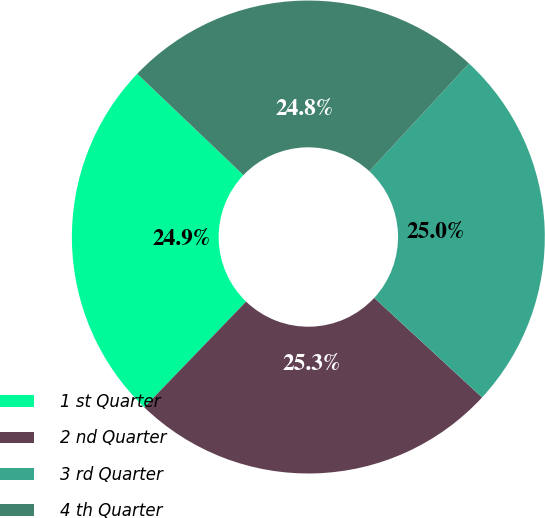Convert chart to OTSL. <chart><loc_0><loc_0><loc_500><loc_500><pie_chart><fcel>1 st Quarter<fcel>2 nd Quarter<fcel>3 rd Quarter<fcel>4 th Quarter<nl><fcel>24.92%<fcel>25.34%<fcel>24.98%<fcel>24.77%<nl></chart> 